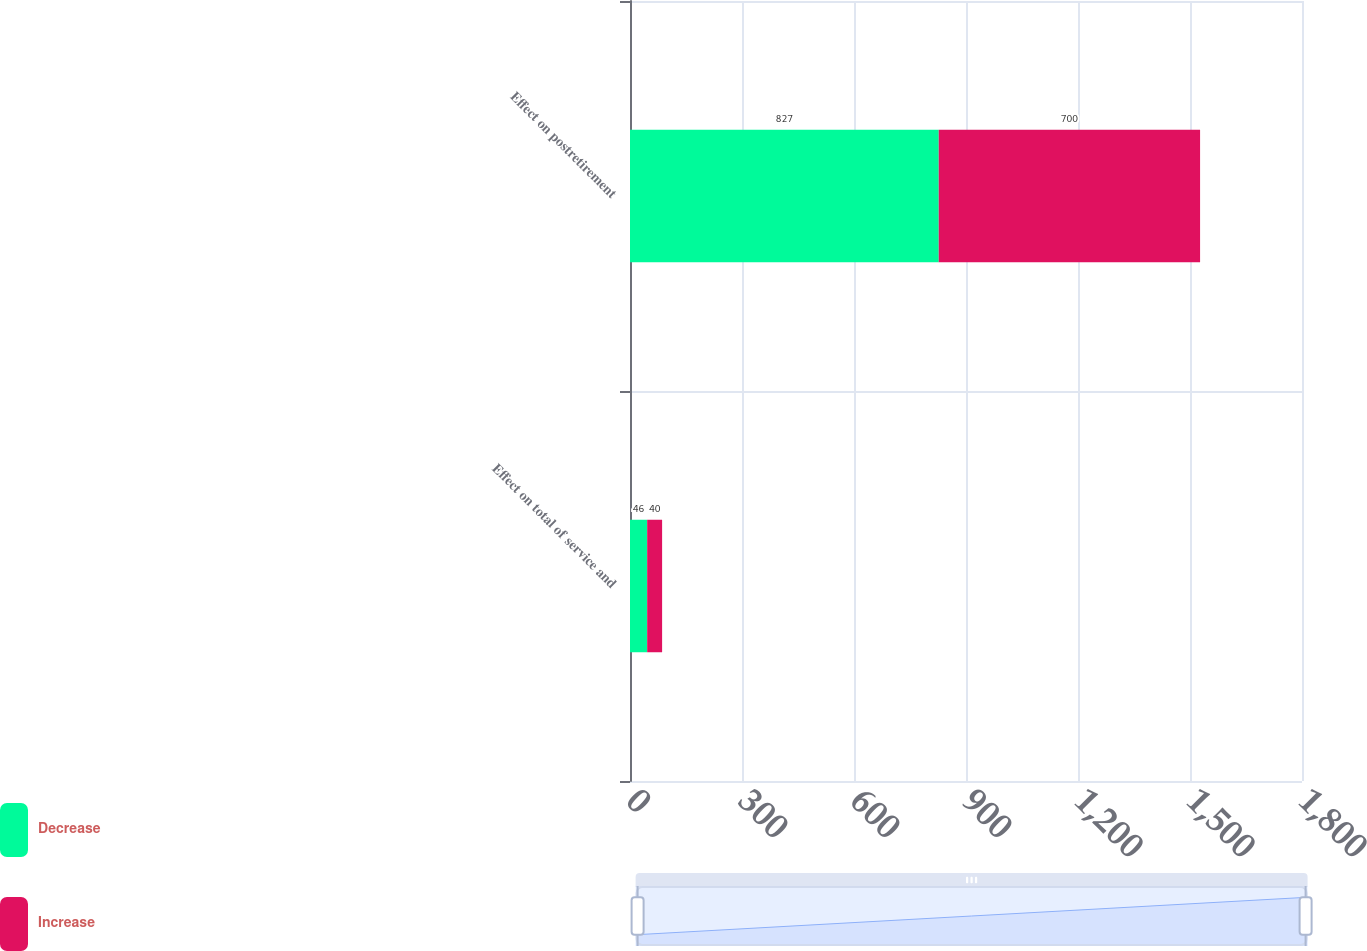Convert chart to OTSL. <chart><loc_0><loc_0><loc_500><loc_500><stacked_bar_chart><ecel><fcel>Effect on total of service and<fcel>Effect on postretirement<nl><fcel>Decrease<fcel>46<fcel>827<nl><fcel>Increase<fcel>40<fcel>700<nl></chart> 